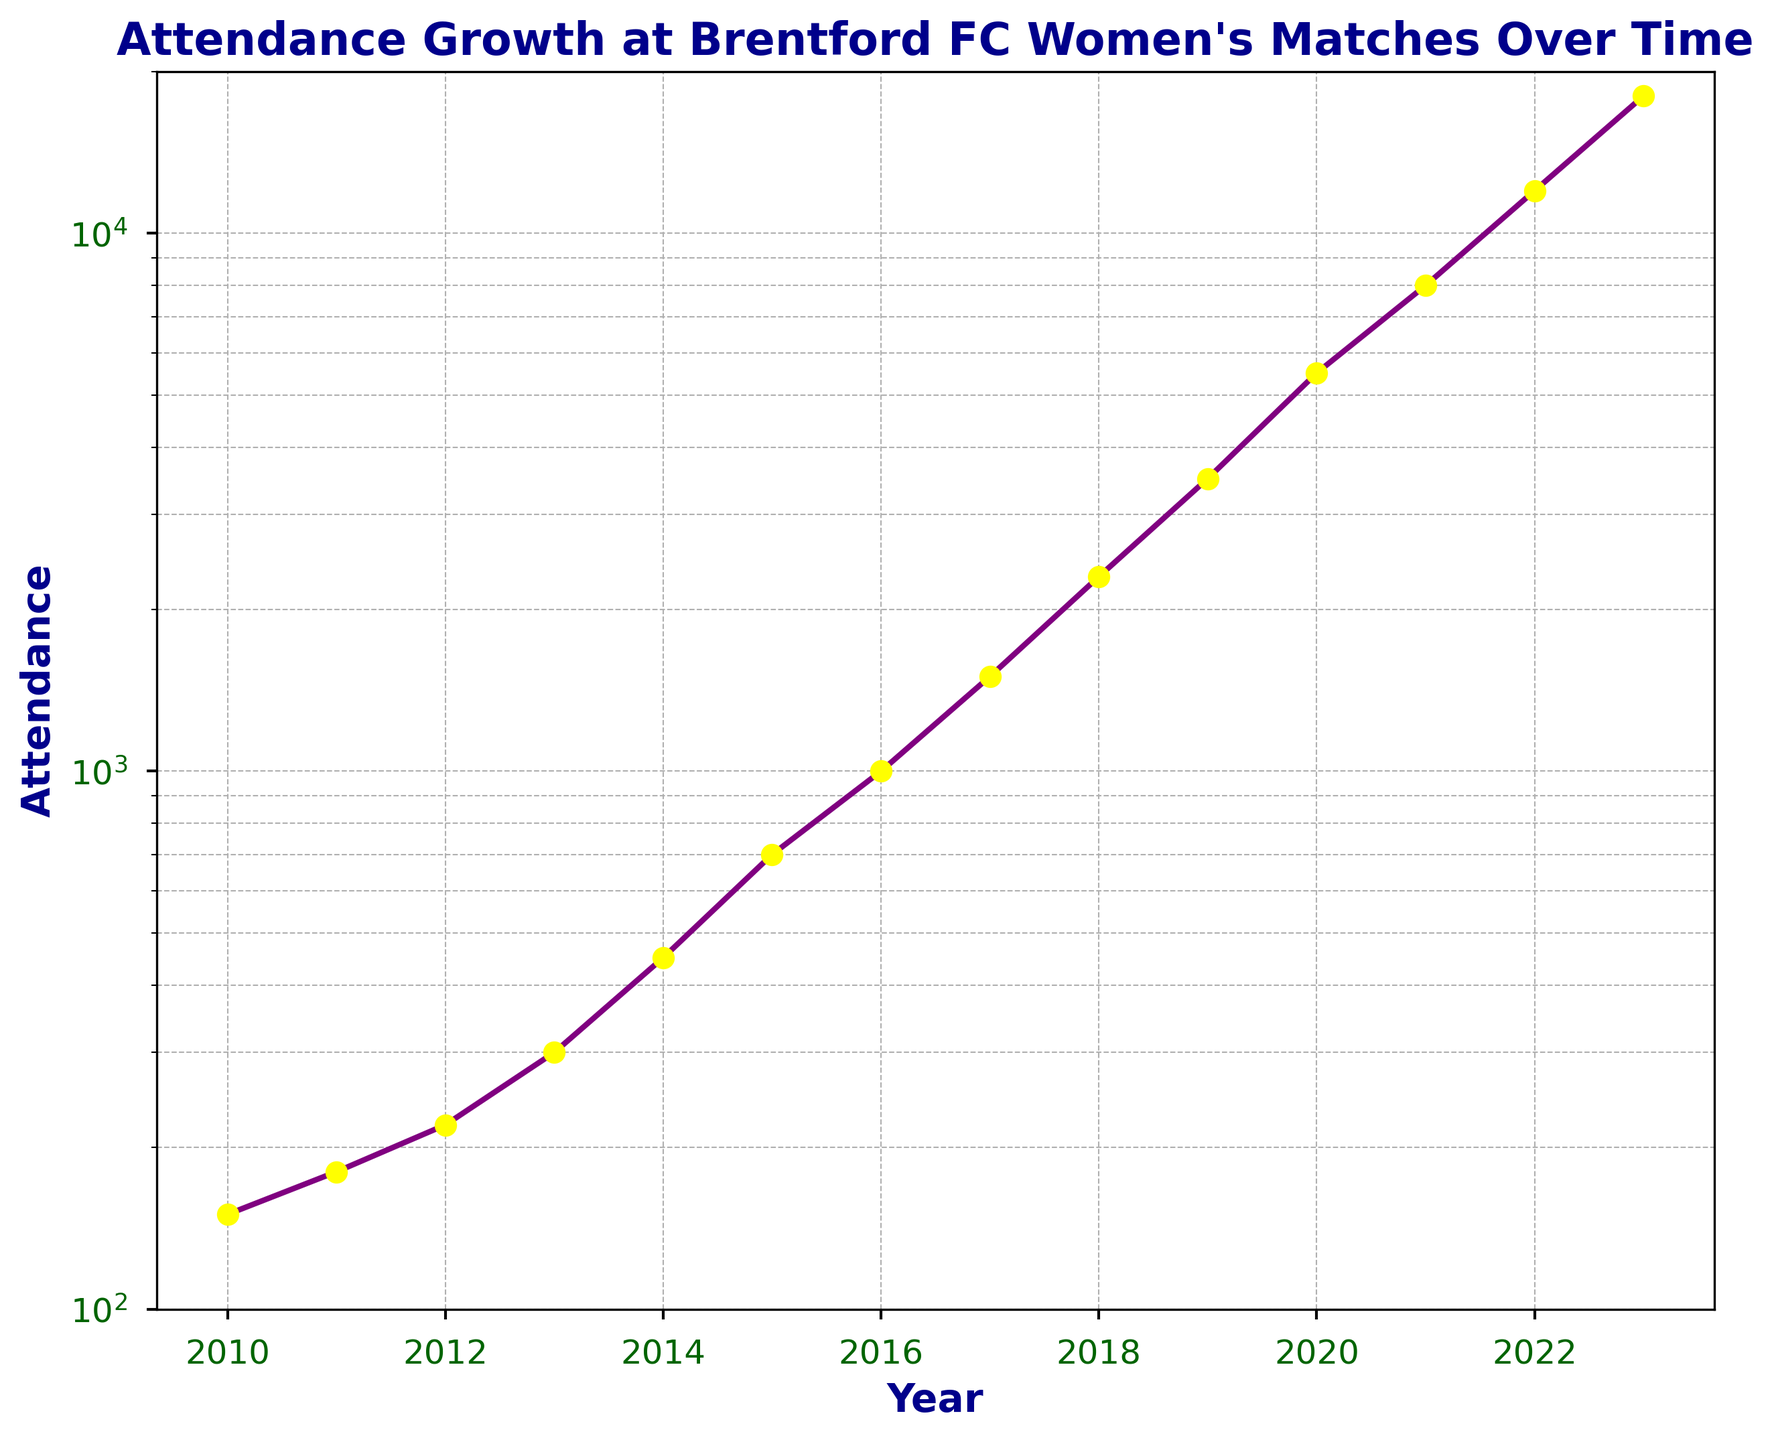What's the attendance in the year 2015? The line plot shows the attendance value for the year 2015 clearly, which is marked by a point on the line
Answer: 700 What was the percentage increase in attendance from 2021 to 2022? First, find the attendance values for both years (8000 in 2021 and 12000 in 2022). Calculate the difference: 12000 - 8000 = 4000. Then, divide the increase by the 2021 value: 4000 / 8000 = 0.5. Finally, convert to a percentage: 0.5 * 100 = 50%
Answer: 50% Between which two years did the attendance at women's matches experience the highest absolute increase? To find this, subtract the attendance values of consecutive years and see which difference is largest: 
- 2022 - 2021 = 12000 - 8000 = 4000
- 2023 - 2022 = 18000 - 12000 = 6000 
The highest increase is from 2022 to 2023.
Answer: 2022 to 2023 What's the visual trend observed in the attendance data over the years? The plot shows a general increasing trend in attendance over the years with a noticeable acceleration in recent years. The use of a log scale on the y-axis visually reinforces this growth pattern.
Answer: Increasing How many years did it take for the attendance to grow from 1000 to over 12000? Identify the year when attendance was around 1000 (2016) and the year it surpassed 12000 (2022). Count the number of years between these points: 2022 - 2016 = 6 years
Answer: 6 Compare the attendance growth between the periods 2010-2015 and 2018-2023. Which period saw a greater increase? Calculate growth for both periods:
- 2010 (150) to 2015 (700): 700 - 150 = 550
- 2018 (2300) to 2023 (18000): 18000 - 2300 = 15700
The period 2018-2023 saw a greater increase.
Answer: 2018-2023 What color is the line in the attendance growth chart? The visual color of the line in the chart itself is purple.
Answer: Purple What is the attendance in the midpoint year between 2012 and 2022? The midpoint year is (2012 + 2022) / 2 = 2017. The attendance value in 2017 is identified from the plot.
Answer: 1500 